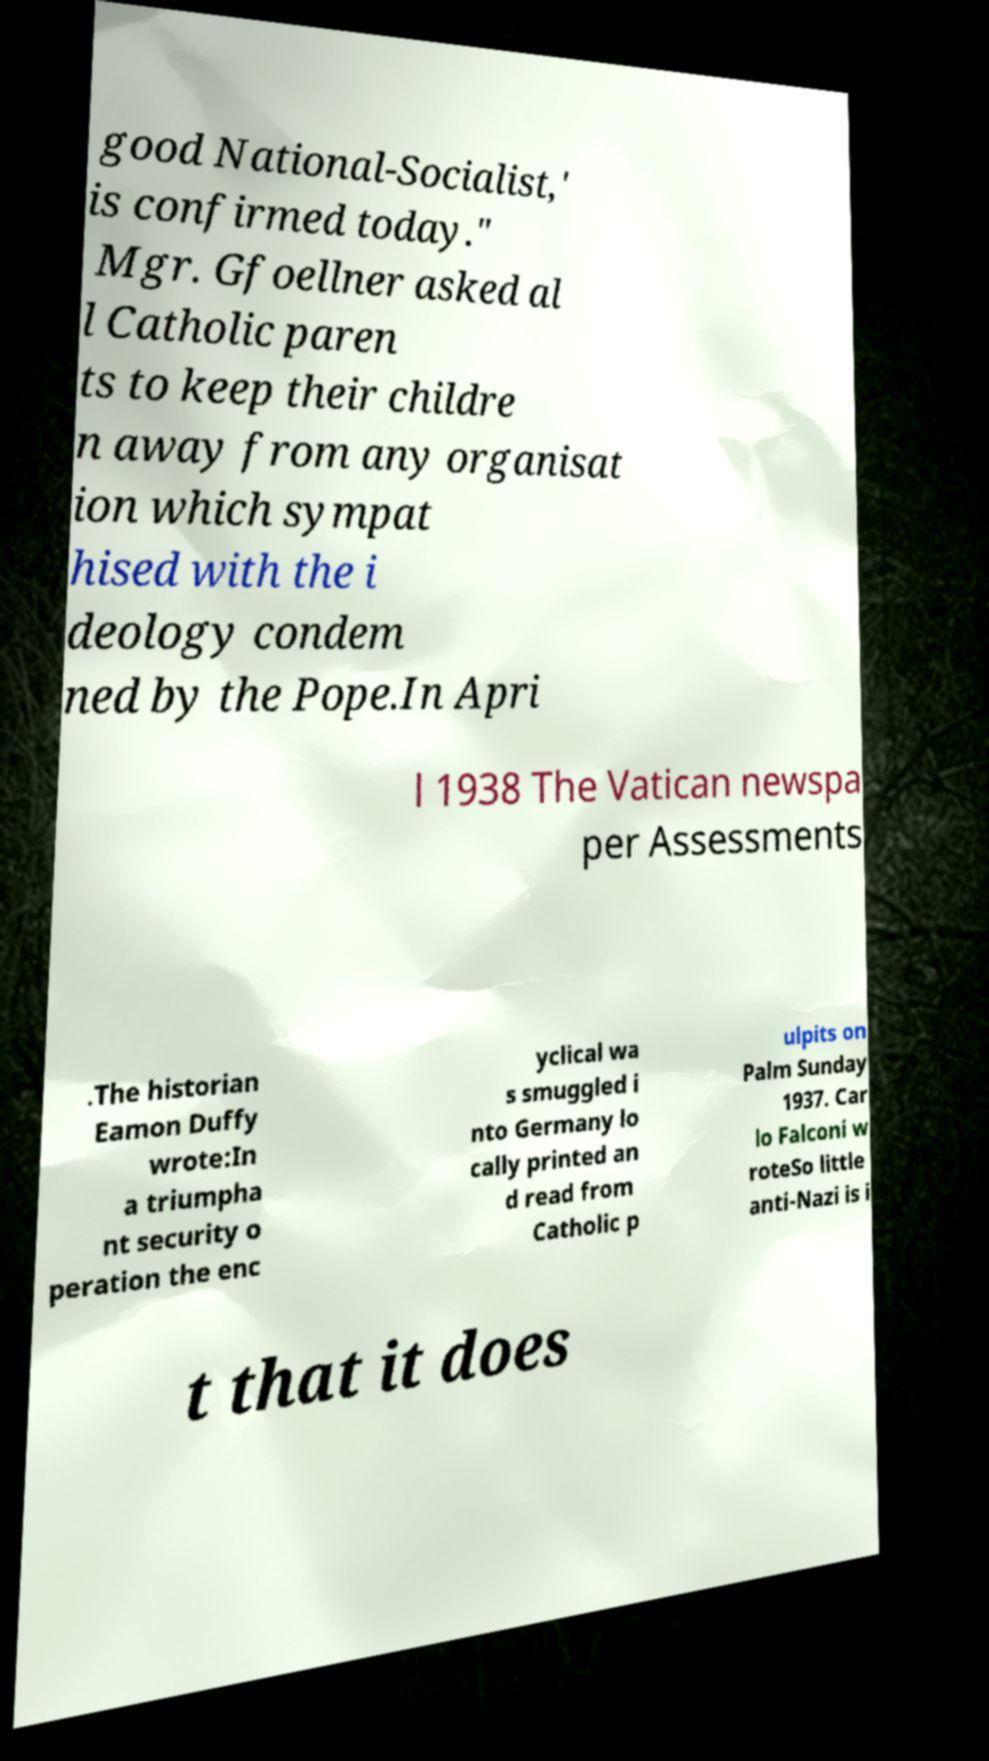Please read and relay the text visible in this image. What does it say? good National-Socialist,' is confirmed today." Mgr. Gfoellner asked al l Catholic paren ts to keep their childre n away from any organisat ion which sympat hised with the i deology condem ned by the Pope.In Apri l 1938 The Vatican newspa per Assessments .The historian Eamon Duffy wrote:In a triumpha nt security o peration the enc yclical wa s smuggled i nto Germany lo cally printed an d read from Catholic p ulpits on Palm Sunday 1937. Car lo Falconi w roteSo little anti-Nazi is i t that it does 